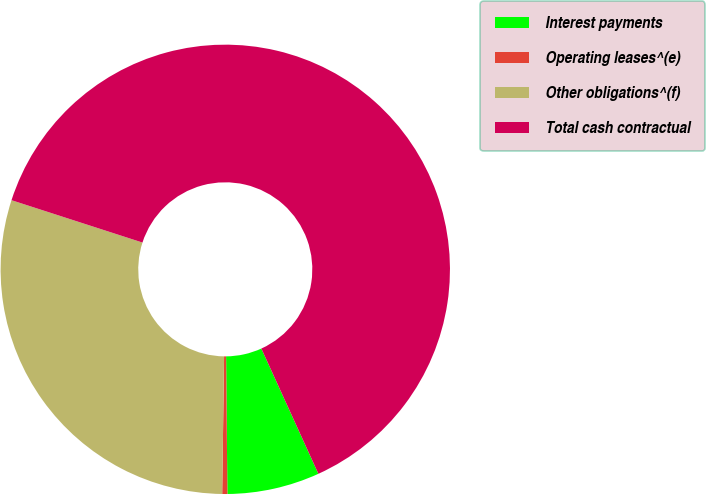<chart> <loc_0><loc_0><loc_500><loc_500><pie_chart><fcel>Interest payments<fcel>Operating leases^(e)<fcel>Other obligations^(f)<fcel>Total cash contractual<nl><fcel>6.65%<fcel>0.37%<fcel>29.76%<fcel>63.22%<nl></chart> 